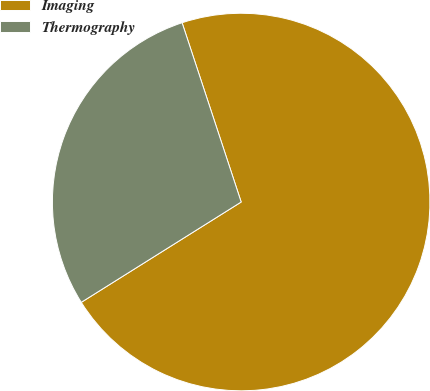Convert chart. <chart><loc_0><loc_0><loc_500><loc_500><pie_chart><fcel>Imaging<fcel>Thermography<nl><fcel>71.15%<fcel>28.85%<nl></chart> 